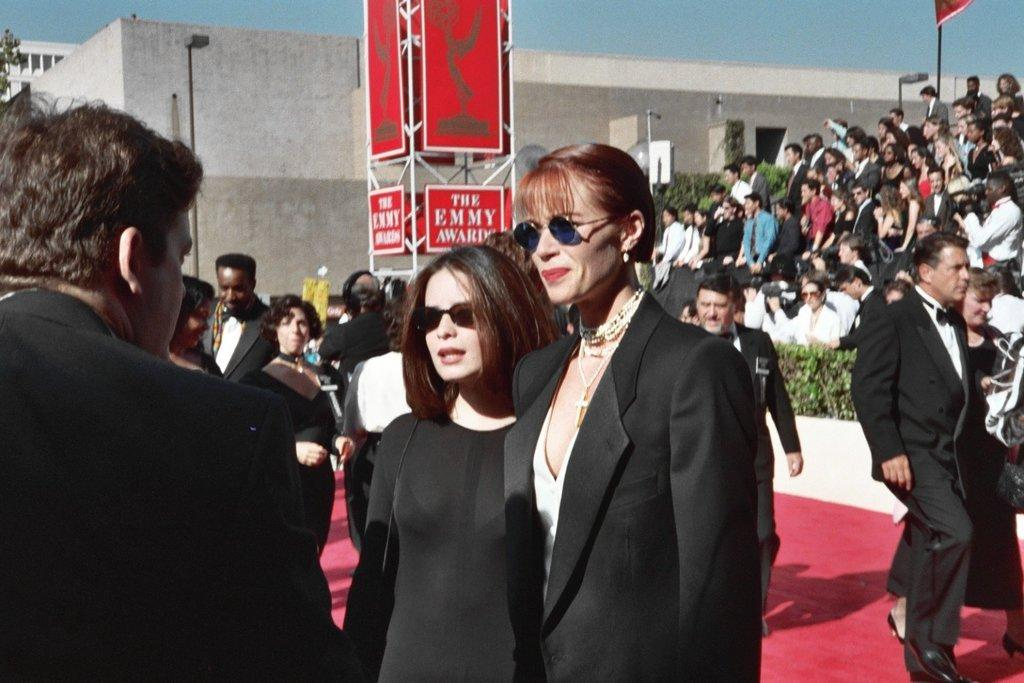How many people are in the image? There is a group of people in the image, but the exact number cannot be determined from the provided facts. What type of vegetation is present in the image? There are plants in the image. What are the poles used for in the image? The purpose of the poles cannot be determined from the provided facts. What are the boards used for in the image? The purpose of the boards cannot be determined from the provided facts. What type of structures can be seen in the image? There are buildings in the image. What is visible in the background of the image? The sky is visible in the background of the image. What type of paste is being used to hold the buildings together in the image? There is no mention of paste or any adhesive being used to hold the buildings together in the image. 